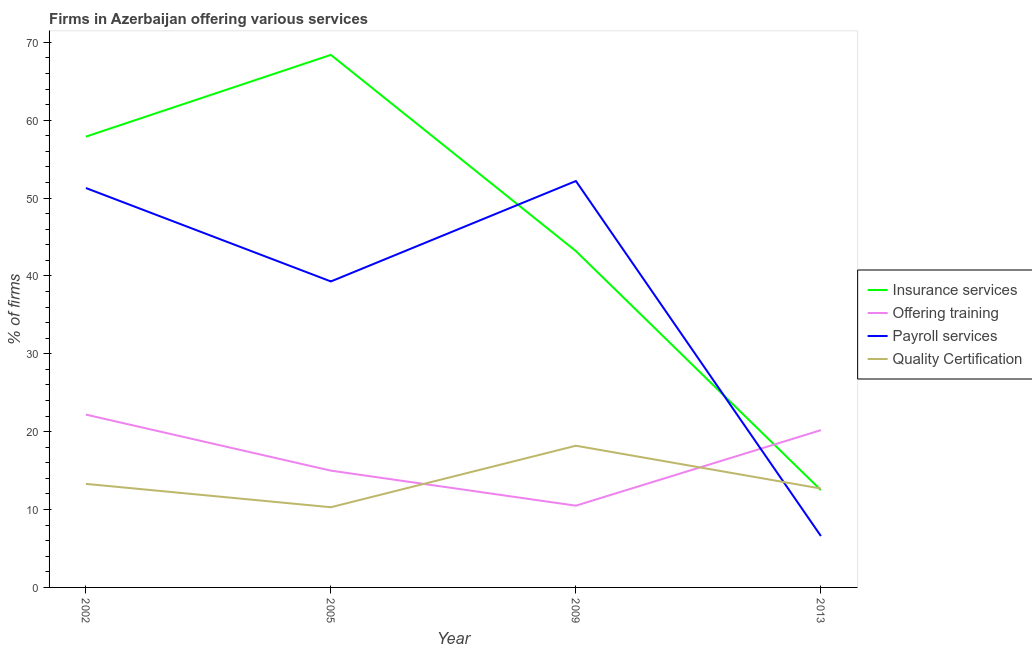How many different coloured lines are there?
Your answer should be compact. 4. What is the percentage of firms offering payroll services in 2009?
Provide a succinct answer. 52.2. Across all years, what is the minimum percentage of firms offering quality certification?
Offer a terse response. 10.3. In which year was the percentage of firms offering quality certification maximum?
Provide a succinct answer. 2009. In which year was the percentage of firms offering quality certification minimum?
Provide a succinct answer. 2005. What is the total percentage of firms offering training in the graph?
Your response must be concise. 67.9. What is the difference between the percentage of firms offering payroll services in 2002 and that in 2009?
Keep it short and to the point. -0.9. What is the difference between the percentage of firms offering quality certification in 2002 and the percentage of firms offering training in 2013?
Make the answer very short. -6.9. What is the average percentage of firms offering quality certification per year?
Give a very brief answer. 13.62. In the year 2005, what is the difference between the percentage of firms offering training and percentage of firms offering payroll services?
Ensure brevity in your answer.  -24.3. What is the ratio of the percentage of firms offering quality certification in 2002 to that in 2005?
Your answer should be compact. 1.29. Is the percentage of firms offering insurance services in 2002 less than that in 2009?
Your answer should be compact. No. Is the difference between the percentage of firms offering insurance services in 2009 and 2013 greater than the difference between the percentage of firms offering payroll services in 2009 and 2013?
Your response must be concise. No. What is the difference between the highest and the second highest percentage of firms offering insurance services?
Offer a terse response. 10.5. What is the difference between the highest and the lowest percentage of firms offering quality certification?
Make the answer very short. 7.9. Is it the case that in every year, the sum of the percentage of firms offering insurance services and percentage of firms offering training is greater than the percentage of firms offering payroll services?
Give a very brief answer. Yes. What is the difference between two consecutive major ticks on the Y-axis?
Provide a short and direct response. 10. Are the values on the major ticks of Y-axis written in scientific E-notation?
Make the answer very short. No. Where does the legend appear in the graph?
Your answer should be compact. Center right. How many legend labels are there?
Your response must be concise. 4. How are the legend labels stacked?
Your answer should be very brief. Vertical. What is the title of the graph?
Offer a terse response. Firms in Azerbaijan offering various services . What is the label or title of the X-axis?
Your answer should be compact. Year. What is the label or title of the Y-axis?
Keep it short and to the point. % of firms. What is the % of firms of Insurance services in 2002?
Ensure brevity in your answer.  57.9. What is the % of firms in Offering training in 2002?
Provide a succinct answer. 22.2. What is the % of firms in Payroll services in 2002?
Offer a very short reply. 51.3. What is the % of firms in Quality Certification in 2002?
Provide a short and direct response. 13.3. What is the % of firms in Insurance services in 2005?
Your answer should be compact. 68.4. What is the % of firms of Payroll services in 2005?
Give a very brief answer. 39.3. What is the % of firms of Quality Certification in 2005?
Offer a terse response. 10.3. What is the % of firms of Insurance services in 2009?
Your answer should be very brief. 43.2. What is the % of firms of Offering training in 2009?
Ensure brevity in your answer.  10.5. What is the % of firms in Payroll services in 2009?
Your response must be concise. 52.2. What is the % of firms in Quality Certification in 2009?
Provide a short and direct response. 18.2. What is the % of firms of Offering training in 2013?
Offer a terse response. 20.2. What is the % of firms of Payroll services in 2013?
Your response must be concise. 6.6. What is the % of firms in Quality Certification in 2013?
Provide a short and direct response. 12.7. Across all years, what is the maximum % of firms in Insurance services?
Provide a short and direct response. 68.4. Across all years, what is the maximum % of firms of Offering training?
Make the answer very short. 22.2. Across all years, what is the maximum % of firms in Payroll services?
Offer a terse response. 52.2. Across all years, what is the maximum % of firms in Quality Certification?
Your answer should be very brief. 18.2. Across all years, what is the minimum % of firms of Insurance services?
Make the answer very short. 12.5. Across all years, what is the minimum % of firms in Offering training?
Ensure brevity in your answer.  10.5. What is the total % of firms in Insurance services in the graph?
Offer a very short reply. 182. What is the total % of firms of Offering training in the graph?
Keep it short and to the point. 67.9. What is the total % of firms in Payroll services in the graph?
Offer a terse response. 149.4. What is the total % of firms of Quality Certification in the graph?
Provide a succinct answer. 54.5. What is the difference between the % of firms of Insurance services in 2002 and that in 2005?
Give a very brief answer. -10.5. What is the difference between the % of firms of Payroll services in 2002 and that in 2005?
Your response must be concise. 12. What is the difference between the % of firms in Quality Certification in 2002 and that in 2005?
Provide a short and direct response. 3. What is the difference between the % of firms of Insurance services in 2002 and that in 2009?
Make the answer very short. 14.7. What is the difference between the % of firms in Offering training in 2002 and that in 2009?
Offer a terse response. 11.7. What is the difference between the % of firms of Quality Certification in 2002 and that in 2009?
Keep it short and to the point. -4.9. What is the difference between the % of firms in Insurance services in 2002 and that in 2013?
Your answer should be very brief. 45.4. What is the difference between the % of firms of Payroll services in 2002 and that in 2013?
Give a very brief answer. 44.7. What is the difference between the % of firms in Quality Certification in 2002 and that in 2013?
Your response must be concise. 0.6. What is the difference between the % of firms of Insurance services in 2005 and that in 2009?
Offer a terse response. 25.2. What is the difference between the % of firms of Quality Certification in 2005 and that in 2009?
Provide a succinct answer. -7.9. What is the difference between the % of firms of Insurance services in 2005 and that in 2013?
Your response must be concise. 55.9. What is the difference between the % of firms in Payroll services in 2005 and that in 2013?
Provide a short and direct response. 32.7. What is the difference between the % of firms of Quality Certification in 2005 and that in 2013?
Offer a very short reply. -2.4. What is the difference between the % of firms in Insurance services in 2009 and that in 2013?
Make the answer very short. 30.7. What is the difference between the % of firms in Payroll services in 2009 and that in 2013?
Offer a very short reply. 45.6. What is the difference between the % of firms in Quality Certification in 2009 and that in 2013?
Give a very brief answer. 5.5. What is the difference between the % of firms in Insurance services in 2002 and the % of firms in Offering training in 2005?
Your response must be concise. 42.9. What is the difference between the % of firms of Insurance services in 2002 and the % of firms of Quality Certification in 2005?
Your response must be concise. 47.6. What is the difference between the % of firms in Offering training in 2002 and the % of firms in Payroll services in 2005?
Provide a succinct answer. -17.1. What is the difference between the % of firms in Offering training in 2002 and the % of firms in Quality Certification in 2005?
Ensure brevity in your answer.  11.9. What is the difference between the % of firms in Insurance services in 2002 and the % of firms in Offering training in 2009?
Your answer should be compact. 47.4. What is the difference between the % of firms in Insurance services in 2002 and the % of firms in Quality Certification in 2009?
Your answer should be very brief. 39.7. What is the difference between the % of firms in Offering training in 2002 and the % of firms in Payroll services in 2009?
Give a very brief answer. -30. What is the difference between the % of firms in Payroll services in 2002 and the % of firms in Quality Certification in 2009?
Give a very brief answer. 33.1. What is the difference between the % of firms of Insurance services in 2002 and the % of firms of Offering training in 2013?
Provide a short and direct response. 37.7. What is the difference between the % of firms of Insurance services in 2002 and the % of firms of Payroll services in 2013?
Ensure brevity in your answer.  51.3. What is the difference between the % of firms of Insurance services in 2002 and the % of firms of Quality Certification in 2013?
Make the answer very short. 45.2. What is the difference between the % of firms of Payroll services in 2002 and the % of firms of Quality Certification in 2013?
Provide a short and direct response. 38.6. What is the difference between the % of firms in Insurance services in 2005 and the % of firms in Offering training in 2009?
Your answer should be compact. 57.9. What is the difference between the % of firms in Insurance services in 2005 and the % of firms in Quality Certification in 2009?
Ensure brevity in your answer.  50.2. What is the difference between the % of firms in Offering training in 2005 and the % of firms in Payroll services in 2009?
Your answer should be compact. -37.2. What is the difference between the % of firms of Payroll services in 2005 and the % of firms of Quality Certification in 2009?
Offer a very short reply. 21.1. What is the difference between the % of firms in Insurance services in 2005 and the % of firms in Offering training in 2013?
Offer a terse response. 48.2. What is the difference between the % of firms in Insurance services in 2005 and the % of firms in Payroll services in 2013?
Provide a short and direct response. 61.8. What is the difference between the % of firms of Insurance services in 2005 and the % of firms of Quality Certification in 2013?
Make the answer very short. 55.7. What is the difference between the % of firms of Offering training in 2005 and the % of firms of Payroll services in 2013?
Keep it short and to the point. 8.4. What is the difference between the % of firms in Offering training in 2005 and the % of firms in Quality Certification in 2013?
Keep it short and to the point. 2.3. What is the difference between the % of firms of Payroll services in 2005 and the % of firms of Quality Certification in 2013?
Your response must be concise. 26.6. What is the difference between the % of firms of Insurance services in 2009 and the % of firms of Payroll services in 2013?
Your answer should be very brief. 36.6. What is the difference between the % of firms in Insurance services in 2009 and the % of firms in Quality Certification in 2013?
Provide a short and direct response. 30.5. What is the difference between the % of firms in Payroll services in 2009 and the % of firms in Quality Certification in 2013?
Keep it short and to the point. 39.5. What is the average % of firms in Insurance services per year?
Provide a short and direct response. 45.5. What is the average % of firms in Offering training per year?
Provide a short and direct response. 16.98. What is the average % of firms in Payroll services per year?
Offer a very short reply. 37.35. What is the average % of firms of Quality Certification per year?
Keep it short and to the point. 13.62. In the year 2002, what is the difference between the % of firms of Insurance services and % of firms of Offering training?
Your answer should be very brief. 35.7. In the year 2002, what is the difference between the % of firms of Insurance services and % of firms of Payroll services?
Provide a succinct answer. 6.6. In the year 2002, what is the difference between the % of firms of Insurance services and % of firms of Quality Certification?
Keep it short and to the point. 44.6. In the year 2002, what is the difference between the % of firms in Offering training and % of firms in Payroll services?
Your response must be concise. -29.1. In the year 2002, what is the difference between the % of firms of Offering training and % of firms of Quality Certification?
Your response must be concise. 8.9. In the year 2002, what is the difference between the % of firms of Payroll services and % of firms of Quality Certification?
Provide a short and direct response. 38. In the year 2005, what is the difference between the % of firms in Insurance services and % of firms in Offering training?
Ensure brevity in your answer.  53.4. In the year 2005, what is the difference between the % of firms of Insurance services and % of firms of Payroll services?
Provide a short and direct response. 29.1. In the year 2005, what is the difference between the % of firms of Insurance services and % of firms of Quality Certification?
Ensure brevity in your answer.  58.1. In the year 2005, what is the difference between the % of firms of Offering training and % of firms of Payroll services?
Your answer should be compact. -24.3. In the year 2005, what is the difference between the % of firms of Offering training and % of firms of Quality Certification?
Offer a terse response. 4.7. In the year 2009, what is the difference between the % of firms of Insurance services and % of firms of Offering training?
Your answer should be compact. 32.7. In the year 2009, what is the difference between the % of firms in Insurance services and % of firms in Payroll services?
Offer a terse response. -9. In the year 2009, what is the difference between the % of firms of Insurance services and % of firms of Quality Certification?
Provide a succinct answer. 25. In the year 2009, what is the difference between the % of firms in Offering training and % of firms in Payroll services?
Keep it short and to the point. -41.7. In the year 2013, what is the difference between the % of firms of Insurance services and % of firms of Quality Certification?
Your answer should be compact. -0.2. In the year 2013, what is the difference between the % of firms of Offering training and % of firms of Payroll services?
Your response must be concise. 13.6. What is the ratio of the % of firms in Insurance services in 2002 to that in 2005?
Your answer should be very brief. 0.85. What is the ratio of the % of firms in Offering training in 2002 to that in 2005?
Your answer should be compact. 1.48. What is the ratio of the % of firms of Payroll services in 2002 to that in 2005?
Provide a succinct answer. 1.31. What is the ratio of the % of firms in Quality Certification in 2002 to that in 2005?
Provide a succinct answer. 1.29. What is the ratio of the % of firms in Insurance services in 2002 to that in 2009?
Offer a terse response. 1.34. What is the ratio of the % of firms in Offering training in 2002 to that in 2009?
Your answer should be compact. 2.11. What is the ratio of the % of firms of Payroll services in 2002 to that in 2009?
Provide a short and direct response. 0.98. What is the ratio of the % of firms in Quality Certification in 2002 to that in 2009?
Your response must be concise. 0.73. What is the ratio of the % of firms of Insurance services in 2002 to that in 2013?
Your response must be concise. 4.63. What is the ratio of the % of firms of Offering training in 2002 to that in 2013?
Give a very brief answer. 1.1. What is the ratio of the % of firms in Payroll services in 2002 to that in 2013?
Keep it short and to the point. 7.77. What is the ratio of the % of firms in Quality Certification in 2002 to that in 2013?
Ensure brevity in your answer.  1.05. What is the ratio of the % of firms in Insurance services in 2005 to that in 2009?
Your answer should be compact. 1.58. What is the ratio of the % of firms of Offering training in 2005 to that in 2009?
Your answer should be very brief. 1.43. What is the ratio of the % of firms of Payroll services in 2005 to that in 2009?
Ensure brevity in your answer.  0.75. What is the ratio of the % of firms in Quality Certification in 2005 to that in 2009?
Provide a succinct answer. 0.57. What is the ratio of the % of firms in Insurance services in 2005 to that in 2013?
Offer a very short reply. 5.47. What is the ratio of the % of firms of Offering training in 2005 to that in 2013?
Ensure brevity in your answer.  0.74. What is the ratio of the % of firms of Payroll services in 2005 to that in 2013?
Give a very brief answer. 5.95. What is the ratio of the % of firms of Quality Certification in 2005 to that in 2013?
Your answer should be very brief. 0.81. What is the ratio of the % of firms in Insurance services in 2009 to that in 2013?
Your answer should be compact. 3.46. What is the ratio of the % of firms in Offering training in 2009 to that in 2013?
Offer a terse response. 0.52. What is the ratio of the % of firms of Payroll services in 2009 to that in 2013?
Keep it short and to the point. 7.91. What is the ratio of the % of firms in Quality Certification in 2009 to that in 2013?
Offer a terse response. 1.43. What is the difference between the highest and the second highest % of firms of Insurance services?
Keep it short and to the point. 10.5. What is the difference between the highest and the second highest % of firms of Payroll services?
Your answer should be very brief. 0.9. What is the difference between the highest and the second highest % of firms of Quality Certification?
Your response must be concise. 4.9. What is the difference between the highest and the lowest % of firms of Insurance services?
Ensure brevity in your answer.  55.9. What is the difference between the highest and the lowest % of firms of Payroll services?
Make the answer very short. 45.6. 